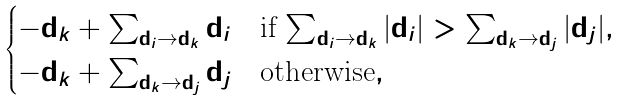<formula> <loc_0><loc_0><loc_500><loc_500>\begin{cases} - { \mathbf d } _ { k } + \sum _ { { \mathbf d } _ { i } \to { \mathbf d } _ { k } } { \mathbf d } _ { i } & \text {if $\sum_{{\mathbf d}_{i} \to {\mathbf d}_{k}} |{\mathbf d}_{i}| > \sum_{{\mathbf d}_{k} \to {\mathbf d}_{j}} |{\mathbf d}_{j}|$} , \\ - { \mathbf d } _ { k } + \sum _ { { \mathbf d } _ { k } \to { \mathbf d } _ { j } } { \mathbf d } _ { j } & \text {otherwise} , \end{cases}</formula> 